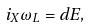Convert formula to latex. <formula><loc_0><loc_0><loc_500><loc_500>i _ { X } \omega _ { L } = d E ,</formula> 